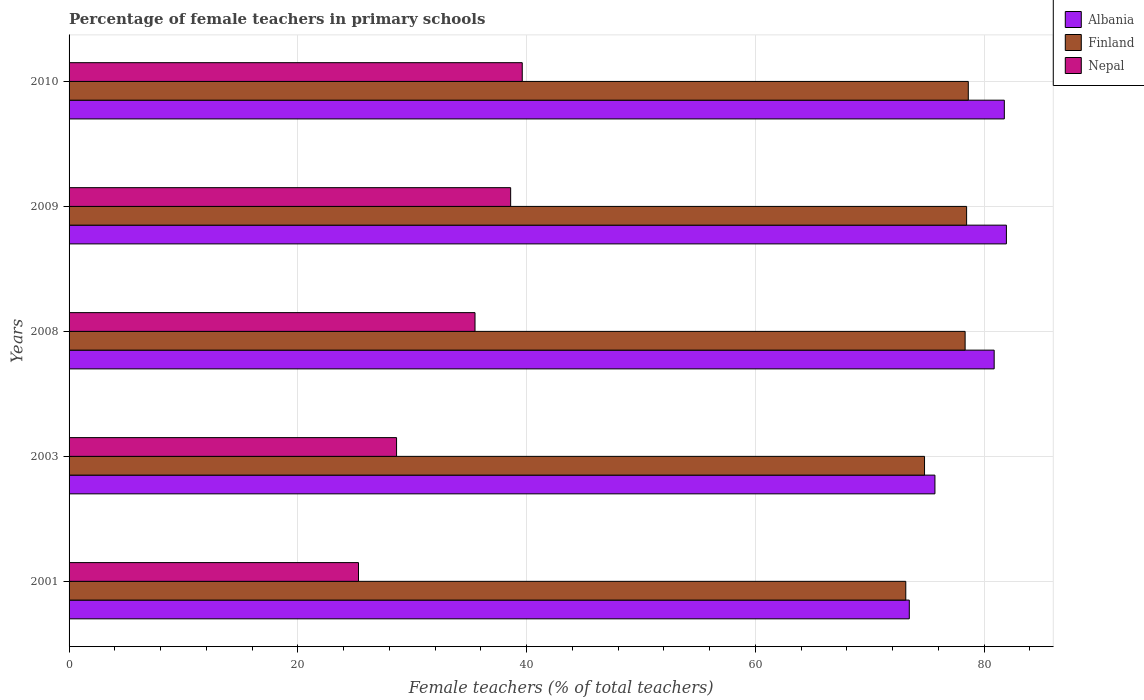How many different coloured bars are there?
Ensure brevity in your answer.  3. How many groups of bars are there?
Offer a very short reply. 5. Are the number of bars per tick equal to the number of legend labels?
Provide a succinct answer. Yes. Are the number of bars on each tick of the Y-axis equal?
Give a very brief answer. Yes. How many bars are there on the 5th tick from the top?
Provide a succinct answer. 3. How many bars are there on the 3rd tick from the bottom?
Your response must be concise. 3. In how many cases, is the number of bars for a given year not equal to the number of legend labels?
Provide a short and direct response. 0. What is the percentage of female teachers in Albania in 2003?
Ensure brevity in your answer.  75.71. Across all years, what is the maximum percentage of female teachers in Nepal?
Offer a very short reply. 39.63. Across all years, what is the minimum percentage of female teachers in Finland?
Offer a very short reply. 73.16. In which year was the percentage of female teachers in Albania minimum?
Offer a very short reply. 2001. What is the total percentage of female teachers in Finland in the graph?
Offer a very short reply. 383.41. What is the difference between the percentage of female teachers in Nepal in 2008 and that in 2009?
Make the answer very short. -3.12. What is the difference between the percentage of female teachers in Nepal in 2001 and the percentage of female teachers in Finland in 2003?
Offer a very short reply. -49.49. What is the average percentage of female teachers in Nepal per year?
Your answer should be compact. 33.53. In the year 2001, what is the difference between the percentage of female teachers in Nepal and percentage of female teachers in Albania?
Your answer should be very brief. -48.16. What is the ratio of the percentage of female teachers in Nepal in 2003 to that in 2010?
Give a very brief answer. 0.72. What is the difference between the highest and the second highest percentage of female teachers in Finland?
Your answer should be compact. 0.15. What is the difference between the highest and the lowest percentage of female teachers in Nepal?
Ensure brevity in your answer.  14.32. In how many years, is the percentage of female teachers in Nepal greater than the average percentage of female teachers in Nepal taken over all years?
Provide a succinct answer. 3. Is the sum of the percentage of female teachers in Albania in 2001 and 2009 greater than the maximum percentage of female teachers in Finland across all years?
Give a very brief answer. Yes. What does the 1st bar from the top in 2010 represents?
Provide a succinct answer. Nepal. What does the 1st bar from the bottom in 2008 represents?
Your response must be concise. Albania. Is it the case that in every year, the sum of the percentage of female teachers in Nepal and percentage of female teachers in Finland is greater than the percentage of female teachers in Albania?
Make the answer very short. Yes. How many bars are there?
Provide a succinct answer. 15. What is the difference between two consecutive major ticks on the X-axis?
Make the answer very short. 20. Are the values on the major ticks of X-axis written in scientific E-notation?
Your answer should be compact. No. Does the graph contain grids?
Provide a succinct answer. Yes. How are the legend labels stacked?
Provide a succinct answer. Vertical. What is the title of the graph?
Ensure brevity in your answer.  Percentage of female teachers in primary schools. Does "Netherlands" appear as one of the legend labels in the graph?
Give a very brief answer. No. What is the label or title of the X-axis?
Keep it short and to the point. Female teachers (% of total teachers). What is the Female teachers (% of total teachers) in Albania in 2001?
Your answer should be compact. 73.47. What is the Female teachers (% of total teachers) of Finland in 2001?
Your response must be concise. 73.16. What is the Female teachers (% of total teachers) of Nepal in 2001?
Offer a very short reply. 25.31. What is the Female teachers (% of total teachers) in Albania in 2003?
Your response must be concise. 75.71. What is the Female teachers (% of total teachers) of Finland in 2003?
Your answer should be very brief. 74.8. What is the Female teachers (% of total teachers) in Nepal in 2003?
Keep it short and to the point. 28.64. What is the Female teachers (% of total teachers) of Albania in 2008?
Offer a terse response. 80.89. What is the Female teachers (% of total teachers) of Finland in 2008?
Make the answer very short. 78.35. What is the Female teachers (% of total teachers) in Nepal in 2008?
Ensure brevity in your answer.  35.5. What is the Female teachers (% of total teachers) in Albania in 2009?
Your response must be concise. 81.96. What is the Female teachers (% of total teachers) in Finland in 2009?
Your answer should be very brief. 78.48. What is the Female teachers (% of total teachers) in Nepal in 2009?
Ensure brevity in your answer.  38.61. What is the Female teachers (% of total teachers) of Albania in 2010?
Keep it short and to the point. 81.78. What is the Female teachers (% of total teachers) in Finland in 2010?
Give a very brief answer. 78.63. What is the Female teachers (% of total teachers) of Nepal in 2010?
Keep it short and to the point. 39.63. Across all years, what is the maximum Female teachers (% of total teachers) of Albania?
Make the answer very short. 81.96. Across all years, what is the maximum Female teachers (% of total teachers) of Finland?
Your answer should be very brief. 78.63. Across all years, what is the maximum Female teachers (% of total teachers) of Nepal?
Make the answer very short. 39.63. Across all years, what is the minimum Female teachers (% of total teachers) in Albania?
Ensure brevity in your answer.  73.47. Across all years, what is the minimum Female teachers (% of total teachers) of Finland?
Your answer should be compact. 73.16. Across all years, what is the minimum Female teachers (% of total teachers) of Nepal?
Provide a short and direct response. 25.31. What is the total Female teachers (% of total teachers) of Albania in the graph?
Your answer should be compact. 393.8. What is the total Female teachers (% of total teachers) of Finland in the graph?
Offer a terse response. 383.41. What is the total Female teachers (% of total teachers) in Nepal in the graph?
Your answer should be compact. 167.67. What is the difference between the Female teachers (% of total teachers) of Albania in 2001 and that in 2003?
Your answer should be very brief. -2.24. What is the difference between the Female teachers (% of total teachers) in Finland in 2001 and that in 2003?
Make the answer very short. -1.64. What is the difference between the Female teachers (% of total teachers) of Nepal in 2001 and that in 2003?
Keep it short and to the point. -3.33. What is the difference between the Female teachers (% of total teachers) of Albania in 2001 and that in 2008?
Your answer should be compact. -7.42. What is the difference between the Female teachers (% of total teachers) in Finland in 2001 and that in 2008?
Offer a terse response. -5.19. What is the difference between the Female teachers (% of total teachers) of Nepal in 2001 and that in 2008?
Offer a terse response. -10.19. What is the difference between the Female teachers (% of total teachers) in Albania in 2001 and that in 2009?
Make the answer very short. -8.49. What is the difference between the Female teachers (% of total teachers) of Finland in 2001 and that in 2009?
Offer a very short reply. -5.32. What is the difference between the Female teachers (% of total teachers) in Nepal in 2001 and that in 2009?
Make the answer very short. -13.3. What is the difference between the Female teachers (% of total teachers) of Albania in 2001 and that in 2010?
Ensure brevity in your answer.  -8.31. What is the difference between the Female teachers (% of total teachers) of Finland in 2001 and that in 2010?
Make the answer very short. -5.47. What is the difference between the Female teachers (% of total teachers) of Nepal in 2001 and that in 2010?
Make the answer very short. -14.32. What is the difference between the Female teachers (% of total teachers) in Albania in 2003 and that in 2008?
Your response must be concise. -5.18. What is the difference between the Female teachers (% of total teachers) of Finland in 2003 and that in 2008?
Ensure brevity in your answer.  -3.55. What is the difference between the Female teachers (% of total teachers) in Nepal in 2003 and that in 2008?
Offer a very short reply. -6.86. What is the difference between the Female teachers (% of total teachers) of Albania in 2003 and that in 2009?
Your response must be concise. -6.25. What is the difference between the Female teachers (% of total teachers) in Finland in 2003 and that in 2009?
Offer a very short reply. -3.68. What is the difference between the Female teachers (% of total teachers) in Nepal in 2003 and that in 2009?
Make the answer very short. -9.97. What is the difference between the Female teachers (% of total teachers) in Albania in 2003 and that in 2010?
Your answer should be very brief. -6.07. What is the difference between the Female teachers (% of total teachers) in Finland in 2003 and that in 2010?
Give a very brief answer. -3.83. What is the difference between the Female teachers (% of total teachers) in Nepal in 2003 and that in 2010?
Keep it short and to the point. -10.99. What is the difference between the Female teachers (% of total teachers) of Albania in 2008 and that in 2009?
Make the answer very short. -1.07. What is the difference between the Female teachers (% of total teachers) of Finland in 2008 and that in 2009?
Offer a terse response. -0.13. What is the difference between the Female teachers (% of total teachers) in Nepal in 2008 and that in 2009?
Offer a terse response. -3.12. What is the difference between the Female teachers (% of total teachers) of Albania in 2008 and that in 2010?
Keep it short and to the point. -0.89. What is the difference between the Female teachers (% of total teachers) of Finland in 2008 and that in 2010?
Provide a succinct answer. -0.28. What is the difference between the Female teachers (% of total teachers) of Nepal in 2008 and that in 2010?
Ensure brevity in your answer.  -4.13. What is the difference between the Female teachers (% of total teachers) in Albania in 2009 and that in 2010?
Your answer should be compact. 0.18. What is the difference between the Female teachers (% of total teachers) in Finland in 2009 and that in 2010?
Ensure brevity in your answer.  -0.15. What is the difference between the Female teachers (% of total teachers) of Nepal in 2009 and that in 2010?
Make the answer very short. -1.01. What is the difference between the Female teachers (% of total teachers) in Albania in 2001 and the Female teachers (% of total teachers) in Finland in 2003?
Offer a terse response. -1.33. What is the difference between the Female teachers (% of total teachers) of Albania in 2001 and the Female teachers (% of total teachers) of Nepal in 2003?
Ensure brevity in your answer.  44.83. What is the difference between the Female teachers (% of total teachers) in Finland in 2001 and the Female teachers (% of total teachers) in Nepal in 2003?
Keep it short and to the point. 44.52. What is the difference between the Female teachers (% of total teachers) in Albania in 2001 and the Female teachers (% of total teachers) in Finland in 2008?
Make the answer very short. -4.88. What is the difference between the Female teachers (% of total teachers) in Albania in 2001 and the Female teachers (% of total teachers) in Nepal in 2008?
Your response must be concise. 37.97. What is the difference between the Female teachers (% of total teachers) in Finland in 2001 and the Female teachers (% of total teachers) in Nepal in 2008?
Ensure brevity in your answer.  37.67. What is the difference between the Female teachers (% of total teachers) in Albania in 2001 and the Female teachers (% of total teachers) in Finland in 2009?
Provide a succinct answer. -5.01. What is the difference between the Female teachers (% of total teachers) of Albania in 2001 and the Female teachers (% of total teachers) of Nepal in 2009?
Make the answer very short. 34.86. What is the difference between the Female teachers (% of total teachers) in Finland in 2001 and the Female teachers (% of total teachers) in Nepal in 2009?
Your answer should be compact. 34.55. What is the difference between the Female teachers (% of total teachers) of Albania in 2001 and the Female teachers (% of total teachers) of Finland in 2010?
Offer a very short reply. -5.16. What is the difference between the Female teachers (% of total teachers) in Albania in 2001 and the Female teachers (% of total teachers) in Nepal in 2010?
Keep it short and to the point. 33.84. What is the difference between the Female teachers (% of total teachers) of Finland in 2001 and the Female teachers (% of total teachers) of Nepal in 2010?
Offer a terse response. 33.54. What is the difference between the Female teachers (% of total teachers) in Albania in 2003 and the Female teachers (% of total teachers) in Finland in 2008?
Your answer should be compact. -2.64. What is the difference between the Female teachers (% of total teachers) of Albania in 2003 and the Female teachers (% of total teachers) of Nepal in 2008?
Offer a terse response. 40.21. What is the difference between the Female teachers (% of total teachers) in Finland in 2003 and the Female teachers (% of total teachers) in Nepal in 2008?
Your response must be concise. 39.3. What is the difference between the Female teachers (% of total teachers) of Albania in 2003 and the Female teachers (% of total teachers) of Finland in 2009?
Your answer should be very brief. -2.77. What is the difference between the Female teachers (% of total teachers) in Albania in 2003 and the Female teachers (% of total teachers) in Nepal in 2009?
Offer a terse response. 37.1. What is the difference between the Female teachers (% of total teachers) of Finland in 2003 and the Female teachers (% of total teachers) of Nepal in 2009?
Offer a terse response. 36.19. What is the difference between the Female teachers (% of total teachers) in Albania in 2003 and the Female teachers (% of total teachers) in Finland in 2010?
Offer a terse response. -2.92. What is the difference between the Female teachers (% of total teachers) in Albania in 2003 and the Female teachers (% of total teachers) in Nepal in 2010?
Your response must be concise. 36.08. What is the difference between the Female teachers (% of total teachers) in Finland in 2003 and the Female teachers (% of total teachers) in Nepal in 2010?
Provide a short and direct response. 35.17. What is the difference between the Female teachers (% of total teachers) in Albania in 2008 and the Female teachers (% of total teachers) in Finland in 2009?
Your response must be concise. 2.41. What is the difference between the Female teachers (% of total teachers) in Albania in 2008 and the Female teachers (% of total teachers) in Nepal in 2009?
Your answer should be very brief. 42.28. What is the difference between the Female teachers (% of total teachers) of Finland in 2008 and the Female teachers (% of total teachers) of Nepal in 2009?
Offer a very short reply. 39.74. What is the difference between the Female teachers (% of total teachers) of Albania in 2008 and the Female teachers (% of total teachers) of Finland in 2010?
Provide a succinct answer. 2.26. What is the difference between the Female teachers (% of total teachers) of Albania in 2008 and the Female teachers (% of total teachers) of Nepal in 2010?
Give a very brief answer. 41.26. What is the difference between the Female teachers (% of total teachers) in Finland in 2008 and the Female teachers (% of total teachers) in Nepal in 2010?
Provide a succinct answer. 38.72. What is the difference between the Female teachers (% of total teachers) of Albania in 2009 and the Female teachers (% of total teachers) of Finland in 2010?
Provide a succinct answer. 3.33. What is the difference between the Female teachers (% of total teachers) in Albania in 2009 and the Female teachers (% of total teachers) in Nepal in 2010?
Your answer should be compact. 42.33. What is the difference between the Female teachers (% of total teachers) of Finland in 2009 and the Female teachers (% of total teachers) of Nepal in 2010?
Make the answer very short. 38.85. What is the average Female teachers (% of total teachers) in Albania per year?
Your answer should be very brief. 78.76. What is the average Female teachers (% of total teachers) in Finland per year?
Ensure brevity in your answer.  76.68. What is the average Female teachers (% of total teachers) of Nepal per year?
Keep it short and to the point. 33.53. In the year 2001, what is the difference between the Female teachers (% of total teachers) of Albania and Female teachers (% of total teachers) of Finland?
Provide a succinct answer. 0.31. In the year 2001, what is the difference between the Female teachers (% of total teachers) of Albania and Female teachers (% of total teachers) of Nepal?
Ensure brevity in your answer.  48.16. In the year 2001, what is the difference between the Female teachers (% of total teachers) in Finland and Female teachers (% of total teachers) in Nepal?
Your answer should be very brief. 47.85. In the year 2003, what is the difference between the Female teachers (% of total teachers) in Albania and Female teachers (% of total teachers) in Finland?
Provide a succinct answer. 0.91. In the year 2003, what is the difference between the Female teachers (% of total teachers) in Albania and Female teachers (% of total teachers) in Nepal?
Provide a succinct answer. 47.07. In the year 2003, what is the difference between the Female teachers (% of total teachers) in Finland and Female teachers (% of total teachers) in Nepal?
Make the answer very short. 46.16. In the year 2008, what is the difference between the Female teachers (% of total teachers) of Albania and Female teachers (% of total teachers) of Finland?
Your response must be concise. 2.54. In the year 2008, what is the difference between the Female teachers (% of total teachers) of Albania and Female teachers (% of total teachers) of Nepal?
Make the answer very short. 45.39. In the year 2008, what is the difference between the Female teachers (% of total teachers) of Finland and Female teachers (% of total teachers) of Nepal?
Provide a succinct answer. 42.85. In the year 2009, what is the difference between the Female teachers (% of total teachers) of Albania and Female teachers (% of total teachers) of Finland?
Offer a terse response. 3.48. In the year 2009, what is the difference between the Female teachers (% of total teachers) in Albania and Female teachers (% of total teachers) in Nepal?
Provide a succinct answer. 43.35. In the year 2009, what is the difference between the Female teachers (% of total teachers) of Finland and Female teachers (% of total teachers) of Nepal?
Your answer should be compact. 39.87. In the year 2010, what is the difference between the Female teachers (% of total teachers) of Albania and Female teachers (% of total teachers) of Finland?
Your response must be concise. 3.15. In the year 2010, what is the difference between the Female teachers (% of total teachers) in Albania and Female teachers (% of total teachers) in Nepal?
Keep it short and to the point. 42.15. In the year 2010, what is the difference between the Female teachers (% of total teachers) of Finland and Female teachers (% of total teachers) of Nepal?
Keep it short and to the point. 39. What is the ratio of the Female teachers (% of total teachers) in Albania in 2001 to that in 2003?
Give a very brief answer. 0.97. What is the ratio of the Female teachers (% of total teachers) in Finland in 2001 to that in 2003?
Your response must be concise. 0.98. What is the ratio of the Female teachers (% of total teachers) of Nepal in 2001 to that in 2003?
Your response must be concise. 0.88. What is the ratio of the Female teachers (% of total teachers) in Albania in 2001 to that in 2008?
Keep it short and to the point. 0.91. What is the ratio of the Female teachers (% of total teachers) of Finland in 2001 to that in 2008?
Provide a short and direct response. 0.93. What is the ratio of the Female teachers (% of total teachers) in Nepal in 2001 to that in 2008?
Offer a very short reply. 0.71. What is the ratio of the Female teachers (% of total teachers) in Albania in 2001 to that in 2009?
Make the answer very short. 0.9. What is the ratio of the Female teachers (% of total teachers) of Finland in 2001 to that in 2009?
Your answer should be compact. 0.93. What is the ratio of the Female teachers (% of total teachers) of Nepal in 2001 to that in 2009?
Your answer should be very brief. 0.66. What is the ratio of the Female teachers (% of total teachers) in Albania in 2001 to that in 2010?
Your answer should be very brief. 0.9. What is the ratio of the Female teachers (% of total teachers) of Finland in 2001 to that in 2010?
Provide a succinct answer. 0.93. What is the ratio of the Female teachers (% of total teachers) of Nepal in 2001 to that in 2010?
Give a very brief answer. 0.64. What is the ratio of the Female teachers (% of total teachers) in Albania in 2003 to that in 2008?
Your response must be concise. 0.94. What is the ratio of the Female teachers (% of total teachers) in Finland in 2003 to that in 2008?
Ensure brevity in your answer.  0.95. What is the ratio of the Female teachers (% of total teachers) of Nepal in 2003 to that in 2008?
Your response must be concise. 0.81. What is the ratio of the Female teachers (% of total teachers) of Albania in 2003 to that in 2009?
Provide a succinct answer. 0.92. What is the ratio of the Female teachers (% of total teachers) in Finland in 2003 to that in 2009?
Offer a terse response. 0.95. What is the ratio of the Female teachers (% of total teachers) of Nepal in 2003 to that in 2009?
Offer a very short reply. 0.74. What is the ratio of the Female teachers (% of total teachers) in Albania in 2003 to that in 2010?
Your answer should be very brief. 0.93. What is the ratio of the Female teachers (% of total teachers) of Finland in 2003 to that in 2010?
Give a very brief answer. 0.95. What is the ratio of the Female teachers (% of total teachers) in Nepal in 2003 to that in 2010?
Your response must be concise. 0.72. What is the ratio of the Female teachers (% of total teachers) in Albania in 2008 to that in 2009?
Make the answer very short. 0.99. What is the ratio of the Female teachers (% of total teachers) of Nepal in 2008 to that in 2009?
Make the answer very short. 0.92. What is the ratio of the Female teachers (% of total teachers) in Albania in 2008 to that in 2010?
Offer a terse response. 0.99. What is the ratio of the Female teachers (% of total teachers) in Finland in 2008 to that in 2010?
Offer a very short reply. 1. What is the ratio of the Female teachers (% of total teachers) in Nepal in 2008 to that in 2010?
Keep it short and to the point. 0.9. What is the ratio of the Female teachers (% of total teachers) of Finland in 2009 to that in 2010?
Make the answer very short. 1. What is the ratio of the Female teachers (% of total teachers) of Nepal in 2009 to that in 2010?
Give a very brief answer. 0.97. What is the difference between the highest and the second highest Female teachers (% of total teachers) of Albania?
Your answer should be compact. 0.18. What is the difference between the highest and the second highest Female teachers (% of total teachers) in Finland?
Your response must be concise. 0.15. What is the difference between the highest and the second highest Female teachers (% of total teachers) in Nepal?
Offer a very short reply. 1.01. What is the difference between the highest and the lowest Female teachers (% of total teachers) in Albania?
Ensure brevity in your answer.  8.49. What is the difference between the highest and the lowest Female teachers (% of total teachers) in Finland?
Keep it short and to the point. 5.47. What is the difference between the highest and the lowest Female teachers (% of total teachers) in Nepal?
Keep it short and to the point. 14.32. 